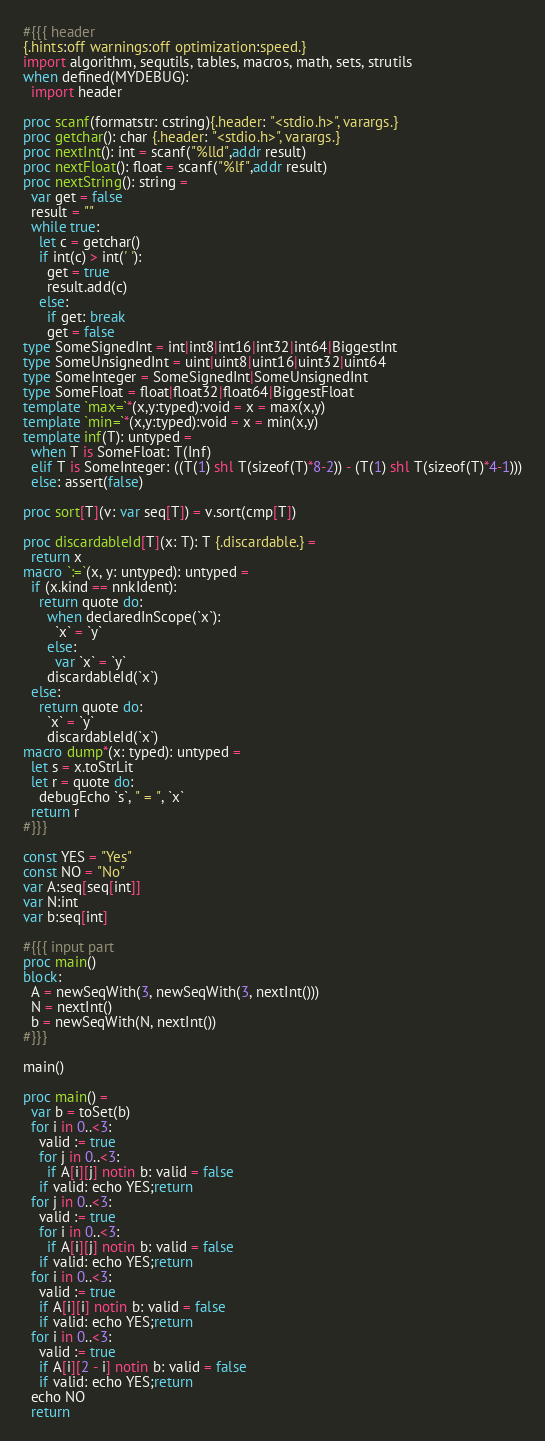Convert code to text. <code><loc_0><loc_0><loc_500><loc_500><_Nim_>#{{{ header
{.hints:off warnings:off optimization:speed.}
import algorithm, sequtils, tables, macros, math, sets, strutils
when defined(MYDEBUG):
  import header

proc scanf(formatstr: cstring){.header: "<stdio.h>", varargs.}
proc getchar(): char {.header: "<stdio.h>", varargs.}
proc nextInt(): int = scanf("%lld",addr result)
proc nextFloat(): float = scanf("%lf",addr result)
proc nextString(): string =
  var get = false
  result = ""
  while true:
    let c = getchar()
    if int(c) > int(' '):
      get = true
      result.add(c)
    else:
      if get: break
      get = false
type SomeSignedInt = int|int8|int16|int32|int64|BiggestInt
type SomeUnsignedInt = uint|uint8|uint16|uint32|uint64
type SomeInteger = SomeSignedInt|SomeUnsignedInt
type SomeFloat = float|float32|float64|BiggestFloat
template `max=`*(x,y:typed):void = x = max(x,y)
template `min=`*(x,y:typed):void = x = min(x,y)
template inf(T): untyped = 
  when T is SomeFloat: T(Inf)
  elif T is SomeInteger: ((T(1) shl T(sizeof(T)*8-2)) - (T(1) shl T(sizeof(T)*4-1)))
  else: assert(false)

proc sort[T](v: var seq[T]) = v.sort(cmp[T])

proc discardableId[T](x: T): T {.discardable.} =
  return x
macro `:=`(x, y: untyped): untyped =
  if (x.kind == nnkIdent):
    return quote do:
      when declaredInScope(`x`):
        `x` = `y`
      else:
        var `x` = `y`
      discardableId(`x`)
  else:
    return quote do:
      `x` = `y`
      discardableId(`x`)
macro dump*(x: typed): untyped =
  let s = x.toStrLit
  let r = quote do:
    debugEcho `s`, " = ", `x`
  return r
#}}}

const YES = "Yes"
const NO = "No"
var A:seq[seq[int]]
var N:int
var b:seq[int]

#{{{ input part
proc main()
block:
  A = newSeqWith(3, newSeqWith(3, nextInt()))
  N = nextInt()
  b = newSeqWith(N, nextInt())
#}}}

main()

proc main() =
  var b = toSet(b)
  for i in 0..<3:
    valid := true
    for j in 0..<3:
      if A[i][j] notin b: valid = false
    if valid: echo YES;return
  for j in 0..<3:
    valid := true
    for i in 0..<3:
      if A[i][j] notin b: valid = false
    if valid: echo YES;return
  for i in 0..<3:
    valid := true
    if A[i][i] notin b: valid = false
    if valid: echo YES;return
  for i in 0..<3:
    valid := true
    if A[i][2 - i] notin b: valid = false
    if valid: echo YES;return
  echo NO
  return
</code> 